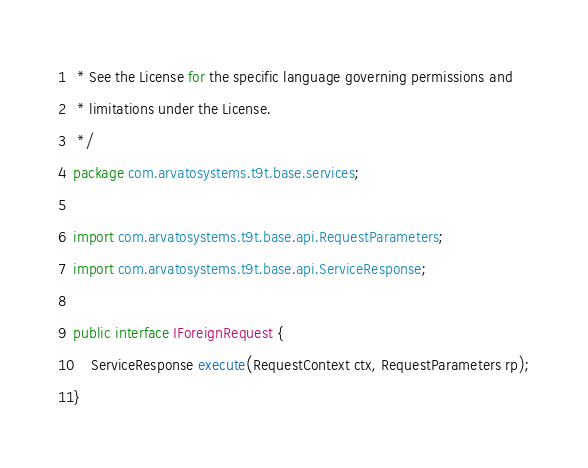Convert code to text. <code><loc_0><loc_0><loc_500><loc_500><_Java_> * See the License for the specific language governing permissions and
 * limitations under the License.
 */
package com.arvatosystems.t9t.base.services;

import com.arvatosystems.t9t.base.api.RequestParameters;
import com.arvatosystems.t9t.base.api.ServiceResponse;

public interface IForeignRequest {
    ServiceResponse execute(RequestContext ctx, RequestParameters rp);
}
</code> 